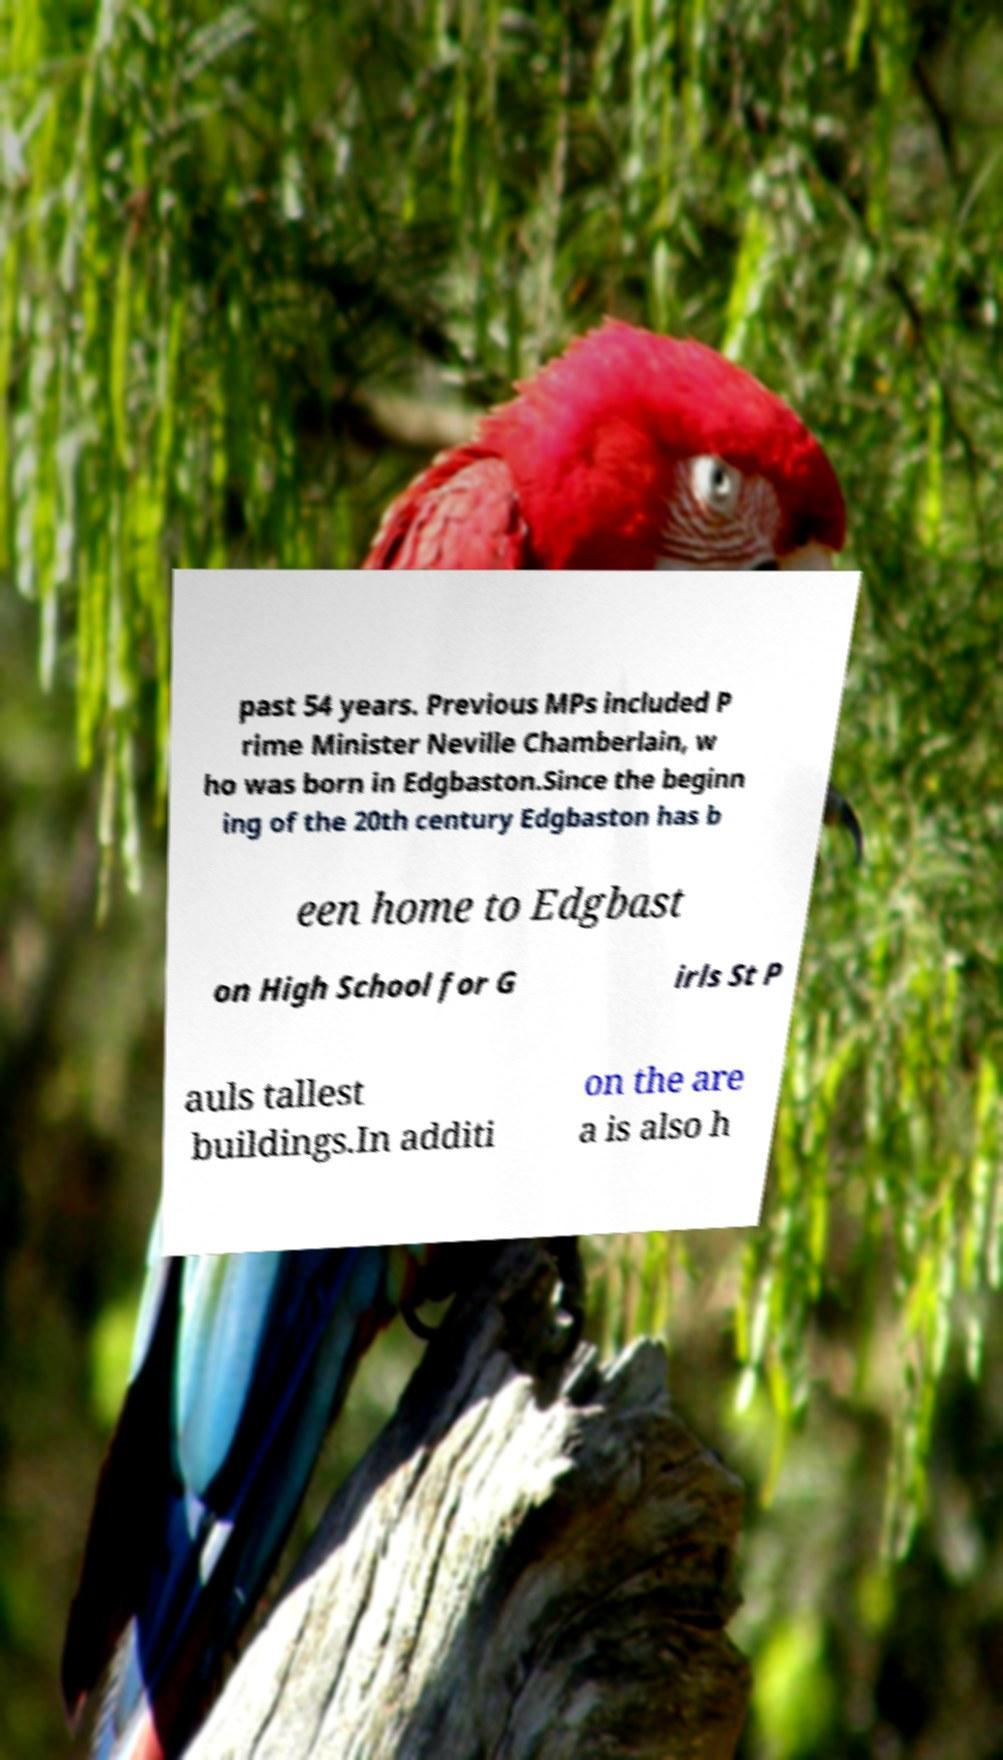Please identify and transcribe the text found in this image. past 54 years. Previous MPs included P rime Minister Neville Chamberlain, w ho was born in Edgbaston.Since the beginn ing of the 20th century Edgbaston has b een home to Edgbast on High School for G irls St P auls tallest buildings.In additi on the are a is also h 